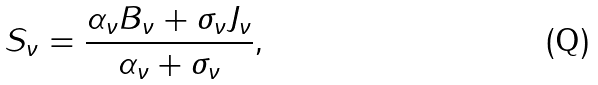Convert formula to latex. <formula><loc_0><loc_0><loc_500><loc_500>S _ { \nu } = \frac { \alpha _ { \nu } B _ { \nu } + \sigma _ { \nu } J _ { \nu } } { \alpha _ { \nu } + \sigma _ { \nu } } ,</formula> 